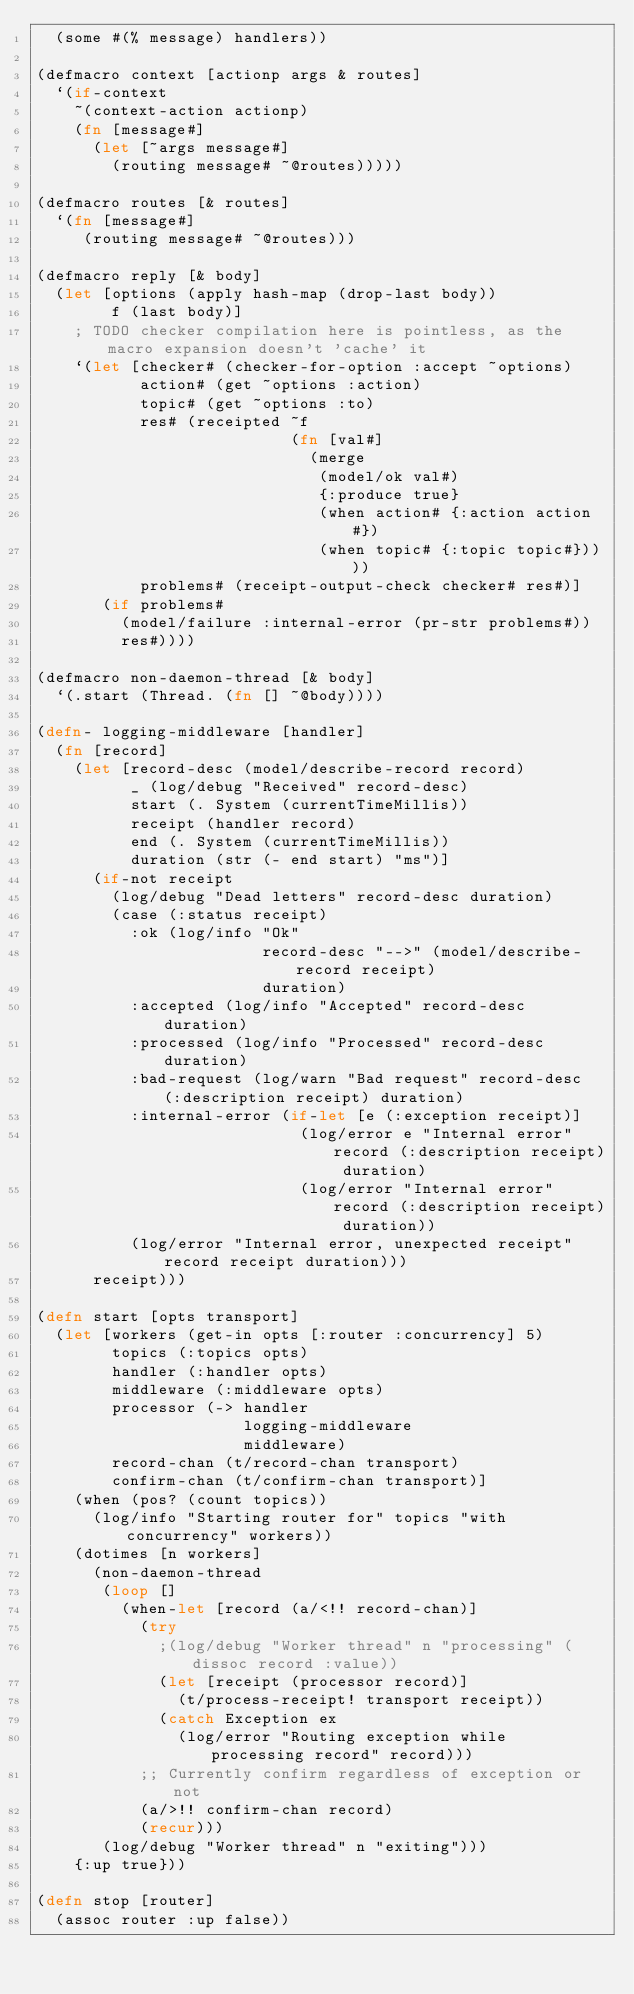Convert code to text. <code><loc_0><loc_0><loc_500><loc_500><_Clojure_>  (some #(% message) handlers))

(defmacro context [actionp args & routes]
  `(if-context
    ~(context-action actionp)
    (fn [message#]
      (let [~args message#]
        (routing message# ~@routes)))))

(defmacro routes [& routes]
  `(fn [message#]
     (routing message# ~@routes)))

(defmacro reply [& body]
  (let [options (apply hash-map (drop-last body))
        f (last body)]
    ; TODO checker compilation here is pointless, as the macro expansion doesn't 'cache' it
    `(let [checker# (checker-for-option :accept ~options)
           action# (get ~options :action)
           topic# (get ~options :to)
           res# (receipted ~f
                           (fn [val#]
                             (merge
                              (model/ok val#)
                              {:produce true}
                              (when action# {:action action#})
                              (when topic# {:topic topic#}))))
           problems# (receipt-output-check checker# res#)]
       (if problems#
         (model/failure :internal-error (pr-str problems#))
         res#))))

(defmacro non-daemon-thread [& body]
  `(.start (Thread. (fn [] ~@body))))

(defn- logging-middleware [handler]
  (fn [record]
    (let [record-desc (model/describe-record record)
          _ (log/debug "Received" record-desc)
          start (. System (currentTimeMillis))
          receipt (handler record)
          end (. System (currentTimeMillis))
          duration (str (- end start) "ms")]
      (if-not receipt
        (log/debug "Dead letters" record-desc duration)
        (case (:status receipt)
          :ok (log/info "Ok"
                        record-desc "-->" (model/describe-record receipt)
                        duration)
          :accepted (log/info "Accepted" record-desc duration)
          :processed (log/info "Processed" record-desc duration)
          :bad-request (log/warn "Bad request" record-desc (:description receipt) duration)
          :internal-error (if-let [e (:exception receipt)]
                            (log/error e "Internal error" record (:description receipt) duration)
                            (log/error "Internal error" record (:description receipt) duration))
          (log/error "Internal error, unexpected receipt" record receipt duration)))
      receipt)))

(defn start [opts transport]
  (let [workers (get-in opts [:router :concurrency] 5)
        topics (:topics opts)
        handler (:handler opts)
        middleware (:middleware opts)
        processor (-> handler
                      logging-middleware
                      middleware)
        record-chan (t/record-chan transport)
        confirm-chan (t/confirm-chan transport)]
    (when (pos? (count topics))
      (log/info "Starting router for" topics "with concurrency" workers))
    (dotimes [n workers]
      (non-daemon-thread
       (loop []
         (when-let [record (a/<!! record-chan)]
           (try
             ;(log/debug "Worker thread" n "processing" (dissoc record :value))
             (let [receipt (processor record)]
               (t/process-receipt! transport receipt))
             (catch Exception ex
               (log/error "Routing exception while processing record" record)))
           ;; Currently confirm regardless of exception or not
           (a/>!! confirm-chan record)
           (recur)))
       (log/debug "Worker thread" n "exiting")))
    {:up true}))

(defn stop [router]
  (assoc router :up false))
</code> 